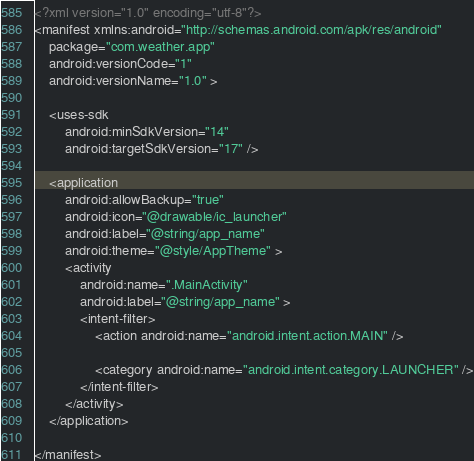<code> <loc_0><loc_0><loc_500><loc_500><_XML_><?xml version="1.0" encoding="utf-8"?>
<manifest xmlns:android="http://schemas.android.com/apk/res/android"
    package="com.weather.app"
    android:versionCode="1"
    android:versionName="1.0" >

    <uses-sdk
        android:minSdkVersion="14"
        android:targetSdkVersion="17" />

    <application
        android:allowBackup="true"
        android:icon="@drawable/ic_launcher"
        android:label="@string/app_name"
        android:theme="@style/AppTheme" >
        <activity
            android:name=".MainActivity"
            android:label="@string/app_name" >
            <intent-filter>
                <action android:name="android.intent.action.MAIN" />

                <category android:name="android.intent.category.LAUNCHER" />
            </intent-filter>
        </activity>
    </application>

</manifest>
</code> 